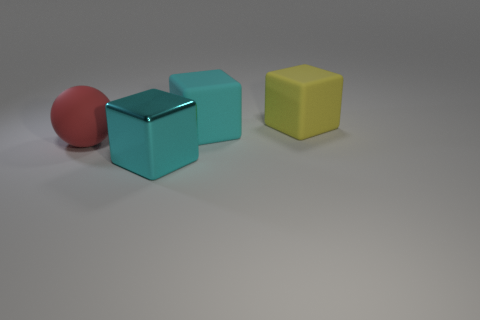Subtract all green balls. How many cyan cubes are left? 2 Add 3 big yellow things. How many objects exist? 7 Subtract all cubes. How many objects are left? 1 Subtract 0 blue blocks. How many objects are left? 4 Subtract all big yellow cubes. Subtract all purple metallic spheres. How many objects are left? 3 Add 2 cyan matte things. How many cyan matte things are left? 3 Add 4 large gray cubes. How many large gray cubes exist? 4 